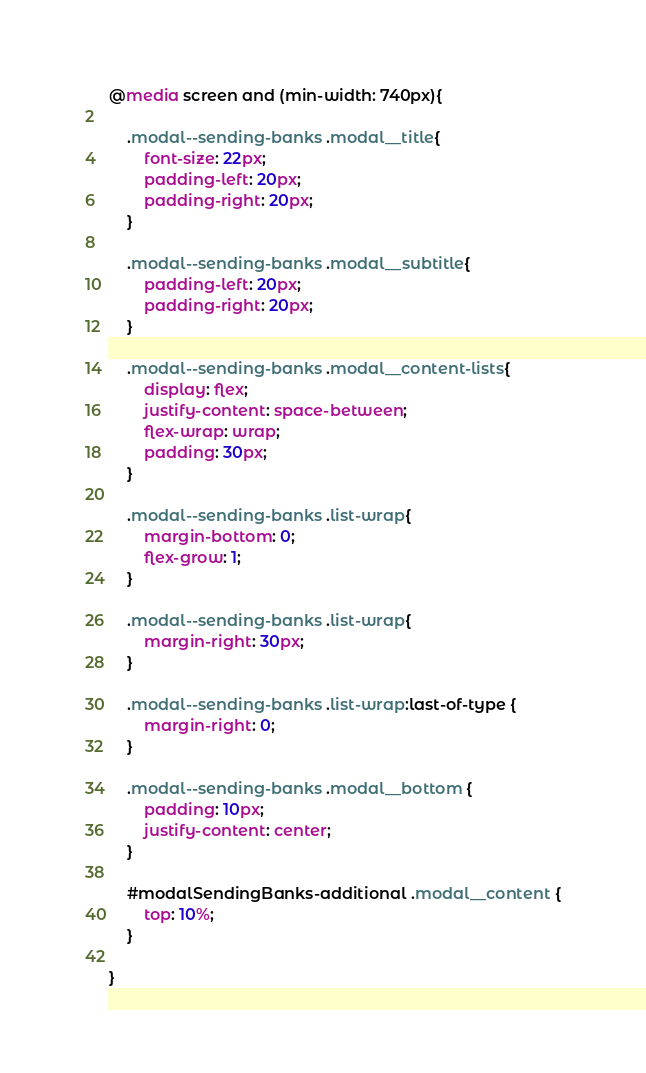<code> <loc_0><loc_0><loc_500><loc_500><_CSS_>@media screen and (min-width: 740px){

    .modal--sending-banks .modal__title{
        font-size: 22px;
        padding-left: 20px;
        padding-right: 20px;
    }

    .modal--sending-banks .modal__subtitle{
        padding-left: 20px;
        padding-right: 20px;
    }

    .modal--sending-banks .modal__content-lists{
        display: flex;
        justify-content: space-between;
        flex-wrap: wrap;
        padding: 30px;
    }

    .modal--sending-banks .list-wrap{
        margin-bottom: 0;
        flex-grow: 1;
    }

    .modal--sending-banks .list-wrap{
        margin-right: 30px;
    }

    .modal--sending-banks .list-wrap:last-of-type {
        margin-right: 0;
    }

    .modal--sending-banks .modal__bottom {
        padding: 10px;
        justify-content: center;
    }

    #modalSendingBanks-additional .modal__content {
        top: 10%;
    }

}

</code> 